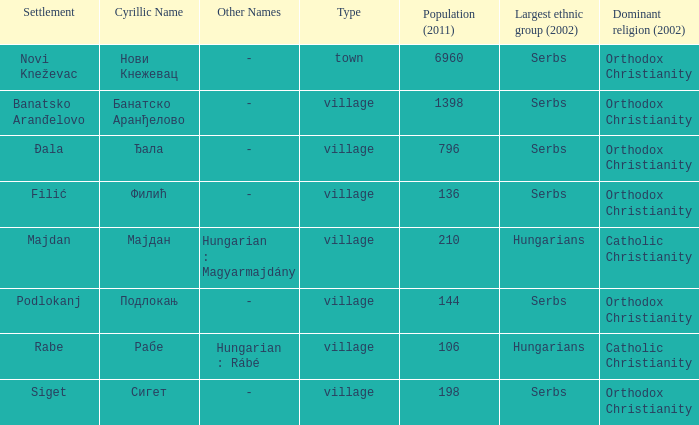What location goes by the cyrillic designation сигет? Siget. 